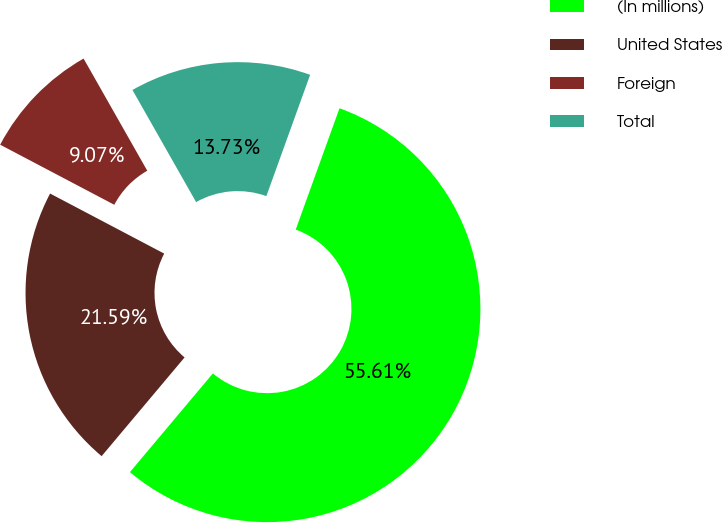Convert chart to OTSL. <chart><loc_0><loc_0><loc_500><loc_500><pie_chart><fcel>(In millions)<fcel>United States<fcel>Foreign<fcel>Total<nl><fcel>55.61%<fcel>21.59%<fcel>9.07%<fcel>13.73%<nl></chart> 